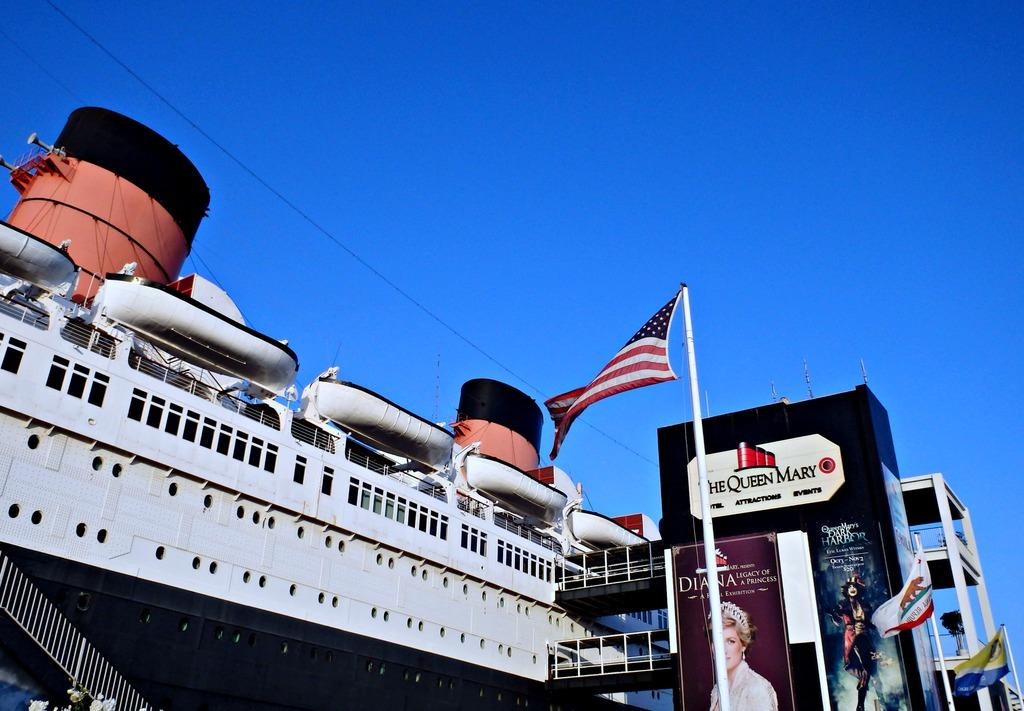What is located on the left side of the image? There is a ship on the left side of the image. What is visible at the top of the image? The sky is visible at the top of the image. What can be seen on the right side of the image? There are banners and a pole on the right side of the image. What is attached to the pole on the right side of the image? Flags are present on the right side of the image. Can you tell me how many dogs are drinking eggnog in the image? There are no dogs or eggnog present in the image. What color is the brain that is hanging from the pole in the image? There is no brain present in the image; only banners, a pole, and flags are visible. 